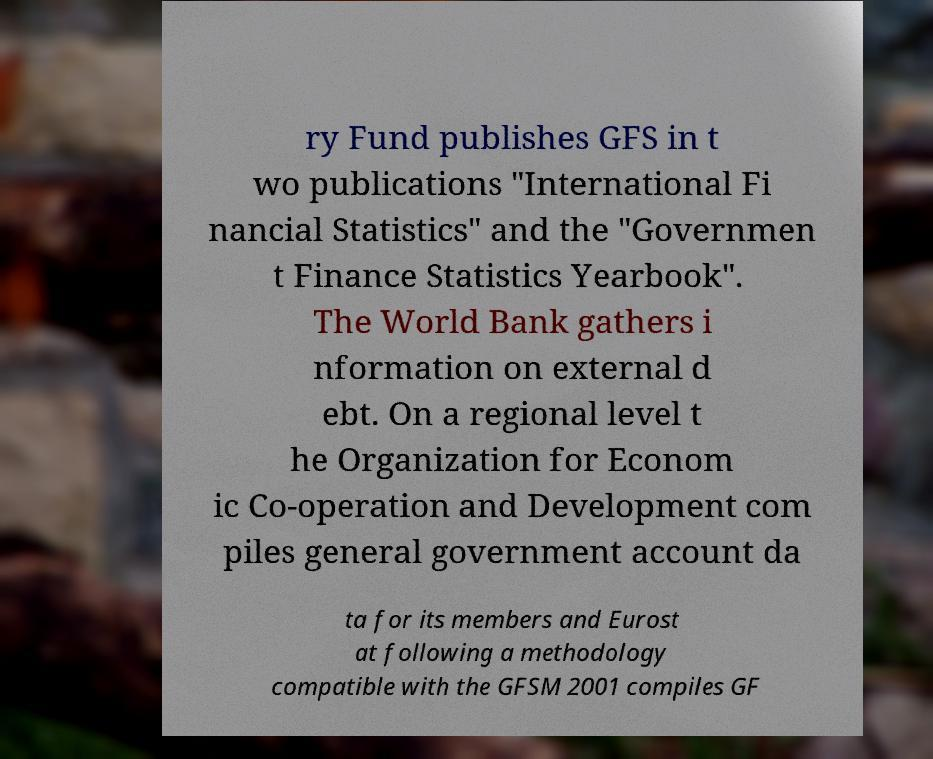Please identify and transcribe the text found in this image. ry Fund publishes GFS in t wo publications "International Fi nancial Statistics" and the "Governmen t Finance Statistics Yearbook". The World Bank gathers i nformation on external d ebt. On a regional level t he Organization for Econom ic Co-operation and Development com piles general government account da ta for its members and Eurost at following a methodology compatible with the GFSM 2001 compiles GF 